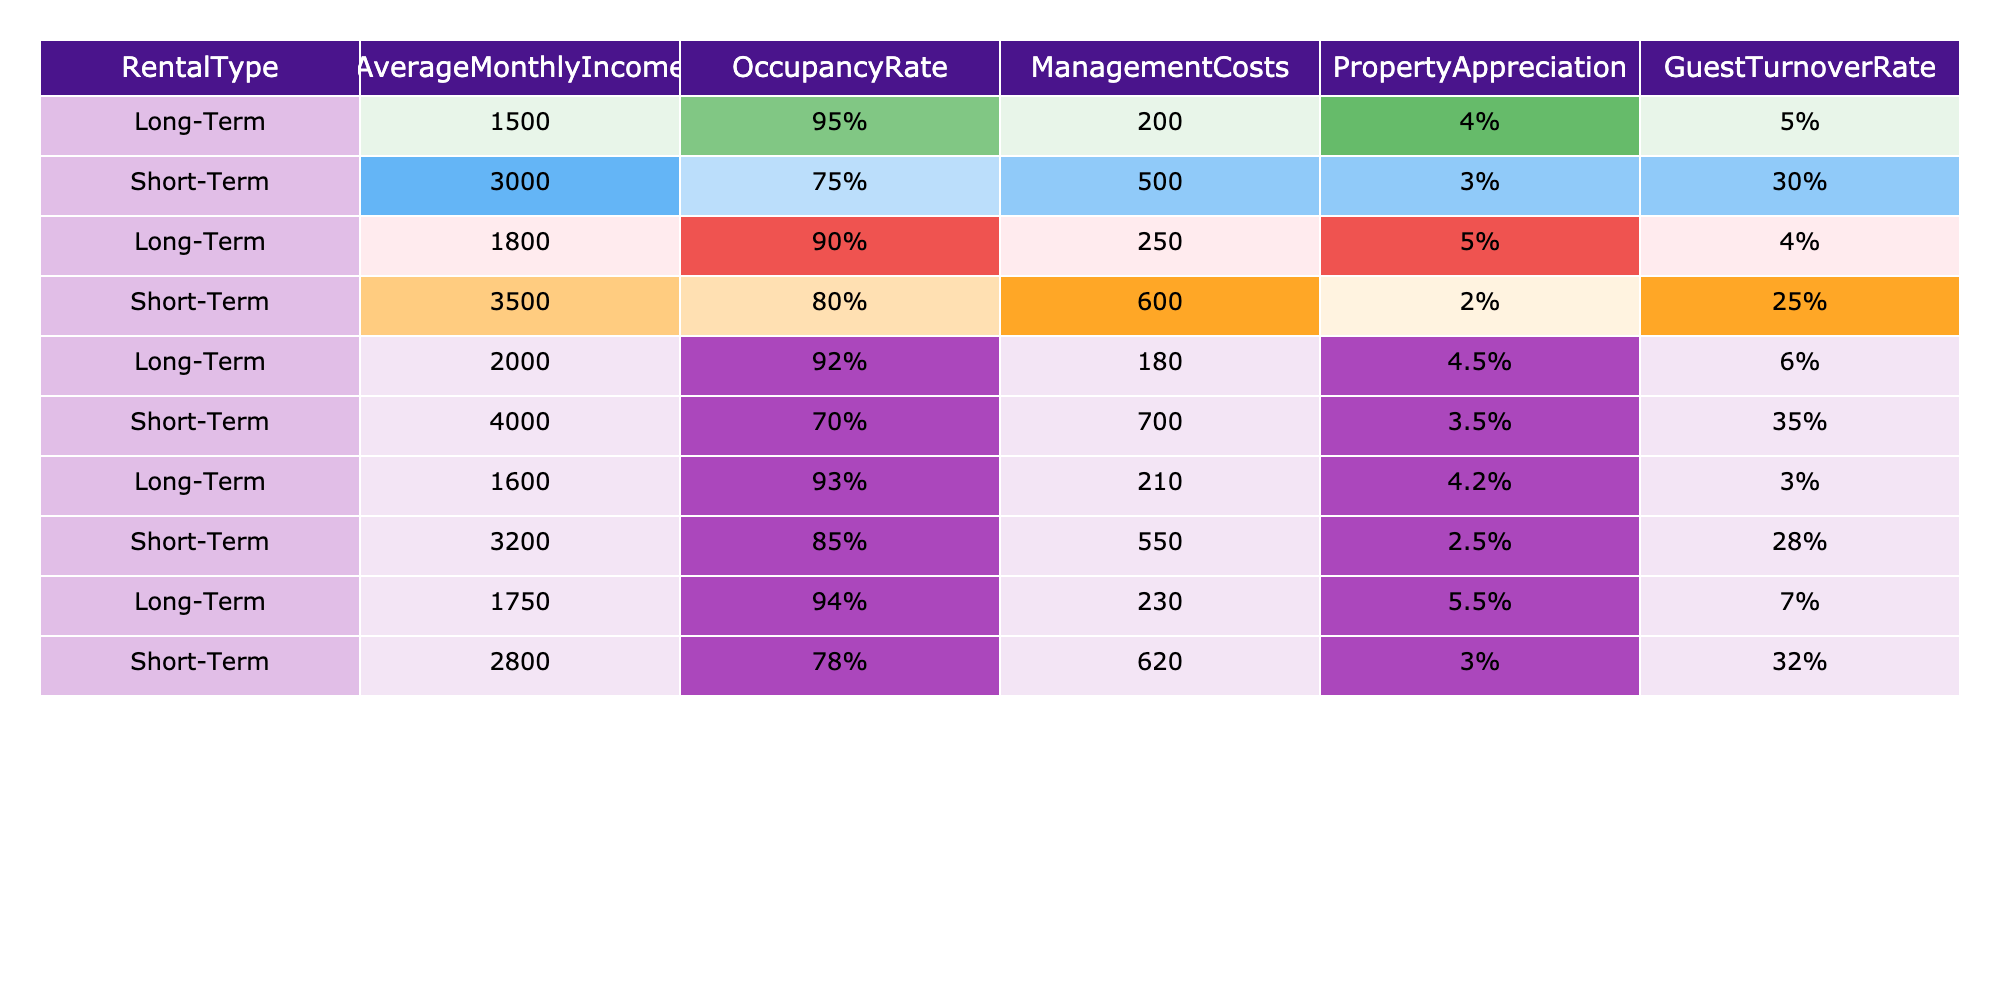What is the highest Average Monthly Income among the rental types? The table shows the Average Monthly Income for Long-Term and Short-Term rentals. Scanning through the values, the highest income is 4000 from the Short-Term category.
Answer: 4000 Which rental type has the highest occupancy rate? The table contains the occupancy rates for both rental types. The Long-Term rentals have rates of 95%, 90%, 92%, 93%, and 94%, while Short-Term rentals have rates of 75%, 80%, 70%, 85%, and 78%. The highest is 95% from Long-Term rentals.
Answer: Long-Term What is the difference in average management costs between Long-Term and Short-Term rentals? The average management costs for Long-Term rentals are calculated as (200 + 250 + 180 + 210 + 230) / 5 = 214, and for Short-Term rentals as (500 + 600 + 700 + 550 + 620) / 5 = 594. The difference is 594 - 214 = 380.
Answer: 380 What is the average property appreciation for Long-Term rentals? The property appreciation values for Long-Term rentals are 4%, 5%, 4.5%, 4.2%, and 5.5%. The average is (4 + 5 + 4.5 + 4.2 + 5.5) / 5 = 4.44%.
Answer: 4.44% Is the guest turnover rate for Short-Term rentals greater than the Long-Term rentals? The guest turnover rates for Long-Term rentals are 5%, 4%, 6%, 3%, and 7%, with an average of 5%. The rates for Short-Term rentals are 30%, 25%, 35%, 28%, and 32%, which average at 30%. Since 30% is greater than 5%, the answer is yes.
Answer: Yes How many of the Long-Term rental entries have an occupancy rate above 90%? Examining the Long-Term rental entries: 95%, 90%, 92%, 93%, and 94%. The occupancy rates above 90% include 95%, 92%, 93%, and 94%, which totals to 4 entries.
Answer: 4 What is the overall average monthly income for both rental types combined? The combined average monthly income is calculated by summing all incomes: (1500 + 3000 + 1800 + 3500 + 2000 + 4000 + 1600 + 3200 + 1750 + 2800) / 10 = 2275.
Answer: 2275 Which rental type has a lower management cost on average? The average management costs were previously calculated as 214 for Long-Term rentals and 594 for Short-Term rentals. Since 214 is lower than 594, Long-Term rentals have lower costs on average.
Answer: Long-Term What is the range of property appreciation for Short-Term rentals? The appreciation values for Short-Term rentals are 3%, 2%, 3.5%, 2.5%, and 3%. The highest value is 3.5% and the lowest is 2%. The range is calculated as 3.5% - 2% = 1.5%.
Answer: 1.5% What is the combined guest turnover rate for Long-Term rentals? The turnover rates for Long-Term rentals are 5%, 4%, 6%, 3%, and 7%. Adding them together gives 25%, and then dividing by the number of entries (5) gives us an average of 5%.
Answer: 5% Are there any Long-Term rental entries with an Average Monthly Income below 1700? The Average Monthly Income for Long-Term rentals from the table is 1500, 1800, 2000, 1600, and 1750. Since 1500 is below 1700, there is at least one entry that meets the criteria.
Answer: Yes 